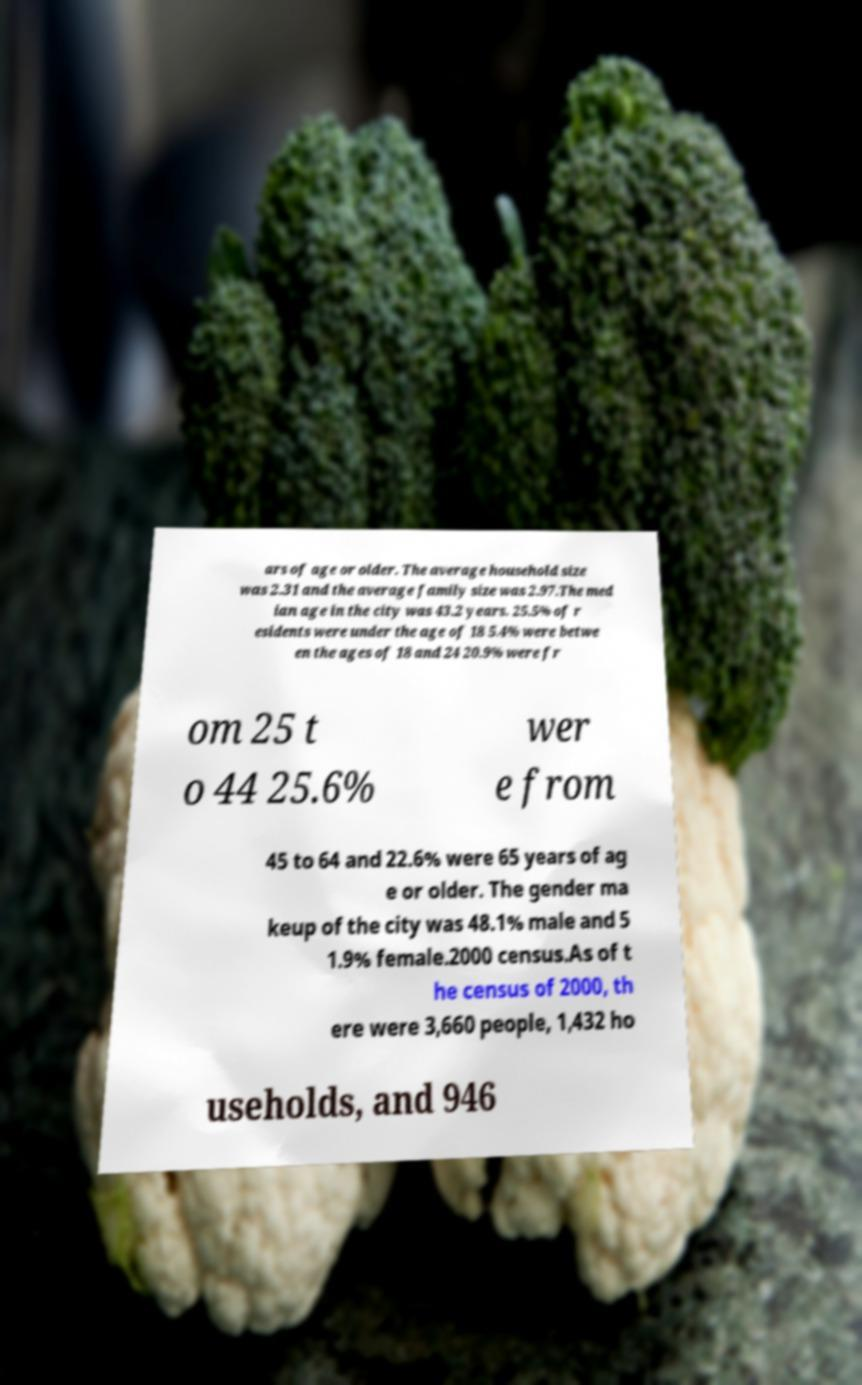Can you accurately transcribe the text from the provided image for me? ars of age or older. The average household size was 2.31 and the average family size was 2.97.The med ian age in the city was 43.2 years. 25.5% of r esidents were under the age of 18 5.4% were betwe en the ages of 18 and 24 20.9% were fr om 25 t o 44 25.6% wer e from 45 to 64 and 22.6% were 65 years of ag e or older. The gender ma keup of the city was 48.1% male and 5 1.9% female.2000 census.As of t he census of 2000, th ere were 3,660 people, 1,432 ho useholds, and 946 